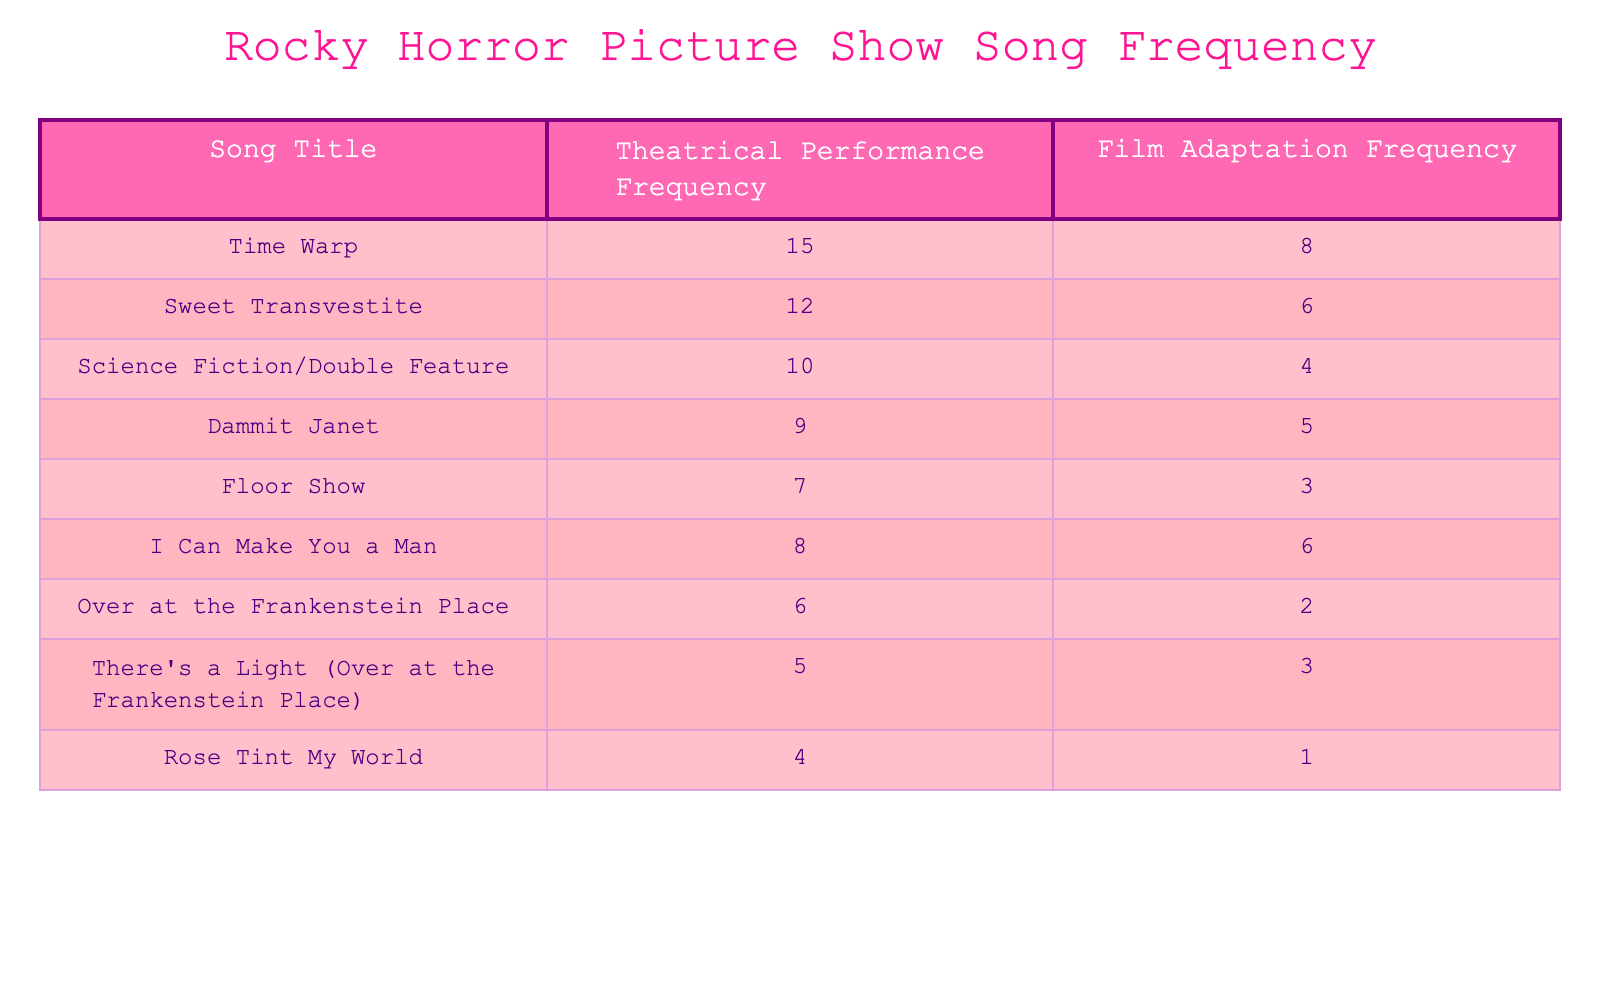What is the frequency of the song "Time Warp" in theatrical performances? The table shows that the theatrical performance frequency for "Time Warp" is listed as 15.
Answer: 15 How many songs have a higher theatrical performance frequency than "Dammit Janet"? To answer this, we can compare the frequency of "Dammit Janet," which is 9, with the frequencies of all other songs. "Time Warp" (15), "Sweet Transvestite" (12), "Science Fiction/Double Feature" (10), and "I Can Make You a Man" (8) have higher frequencies than "Dammit Janet." That totals to 3 songs.
Answer: 3 What song has the lowest frequency in film adaptations? Looking at the table, we see that "Rose Tint My World" has the lowest frequency for film adaptations at 1.
Answer: Rose Tint My World Is the film adaptation frequency of "I Can Make You a Man" greater than the frequency of "Over at the Frankenstein Place"? The film adaptation frequency for "I Can Make You a Man" is 6, while for "Over at the Frankenstein Place" it is 2, which means that "I Can Make You a Man" has a greater frequency.
Answer: Yes What is the total frequency of songs performed in theatrical performances and film adaptations? We need to sum the frequencies for both categories. The total for theatrical performances is 15 + 12 + 10 + 9 + 7 + 8 + 6 + 5 + 4 = 76. The total for film adaptations is 8 + 6 + 4 + 5 + 3 + 6 + 2 + 3 + 1 = 38. Adding these totals gives 76 + 38 = 114.
Answer: 114 How many songs have a film adaptation frequency of less than 5? We examine the film adaptation frequencies: "Science Fiction/Double Feature" (4), "Floor Show" (3), "Over at the Frankenstein Place" (2), and "Rose Tint My World" (1). There are 4 songs with frequencies less than 5.
Answer: 4 What is the difference in theatrical performance frequency between "Sweet Transvestite" and "Floor Show"? The frequency of "Sweet Transvestite" in theatrical performances is 12 and for "Floor Show," it is 7. The difference is 12 - 7 = 5.
Answer: 5 Which song has the highest frequency in both categories combined? We can calculate the combined frequencies for each song: "Time Warp" (15 + 8 = 23), "Sweet Transvestite" (12 + 6 = 18), "Science Fiction/Double Feature" (10 + 4 = 14), "Dammit Janet" (9 + 5 = 14), "Floor Show" (7 + 3 = 10), "I Can Make You a Man" (8 + 6 = 14), "Over at the Frankenstein Place" (6 + 2 = 8), "There's a Light (Over at the Frankenstein Place)" (5 + 3 = 8), and "Rose Tint My World" (4 + 1 = 5). The highest combined frequency is 23 for "Time Warp."
Answer: Time Warp 